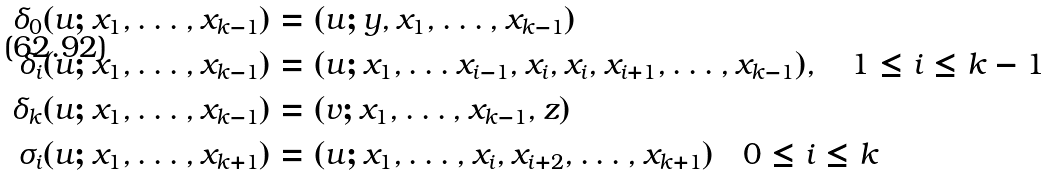Convert formula to latex. <formula><loc_0><loc_0><loc_500><loc_500>\delta _ { 0 } ( u ; x _ { 1 } , \dots , x _ { k - 1 } ) & = ( u ; y , x _ { 1 } , \dots , x _ { k - 1 } ) \\ \delta _ { i } ( u ; x _ { 1 } , \dots , x _ { k - 1 } ) & = ( u ; x _ { 1 } , \dots x _ { i - 1 } , x _ { i } , x _ { i } , x _ { i + 1 } , \dots , x _ { k - 1 } ) , \quad 1 \leq i \leq k - 1 \\ \delta _ { k } ( u ; x _ { 1 } , \dots , x _ { k - 1 } ) & = ( v ; x _ { 1 } , \dots , x _ { k - 1 } , z ) \\ \sigma _ { i } ( u ; x _ { 1 } , \dots , x _ { k + 1 } ) & = ( u ; x _ { 1 } , \dots , x _ { i } , x _ { i + 2 } , \dots , x _ { k + 1 } ) \quad 0 \leq i \leq k</formula> 